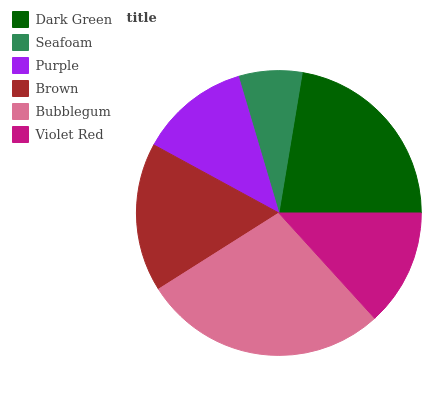Is Seafoam the minimum?
Answer yes or no. Yes. Is Bubblegum the maximum?
Answer yes or no. Yes. Is Purple the minimum?
Answer yes or no. No. Is Purple the maximum?
Answer yes or no. No. Is Purple greater than Seafoam?
Answer yes or no. Yes. Is Seafoam less than Purple?
Answer yes or no. Yes. Is Seafoam greater than Purple?
Answer yes or no. No. Is Purple less than Seafoam?
Answer yes or no. No. Is Brown the high median?
Answer yes or no. Yes. Is Violet Red the low median?
Answer yes or no. Yes. Is Purple the high median?
Answer yes or no. No. Is Brown the low median?
Answer yes or no. No. 